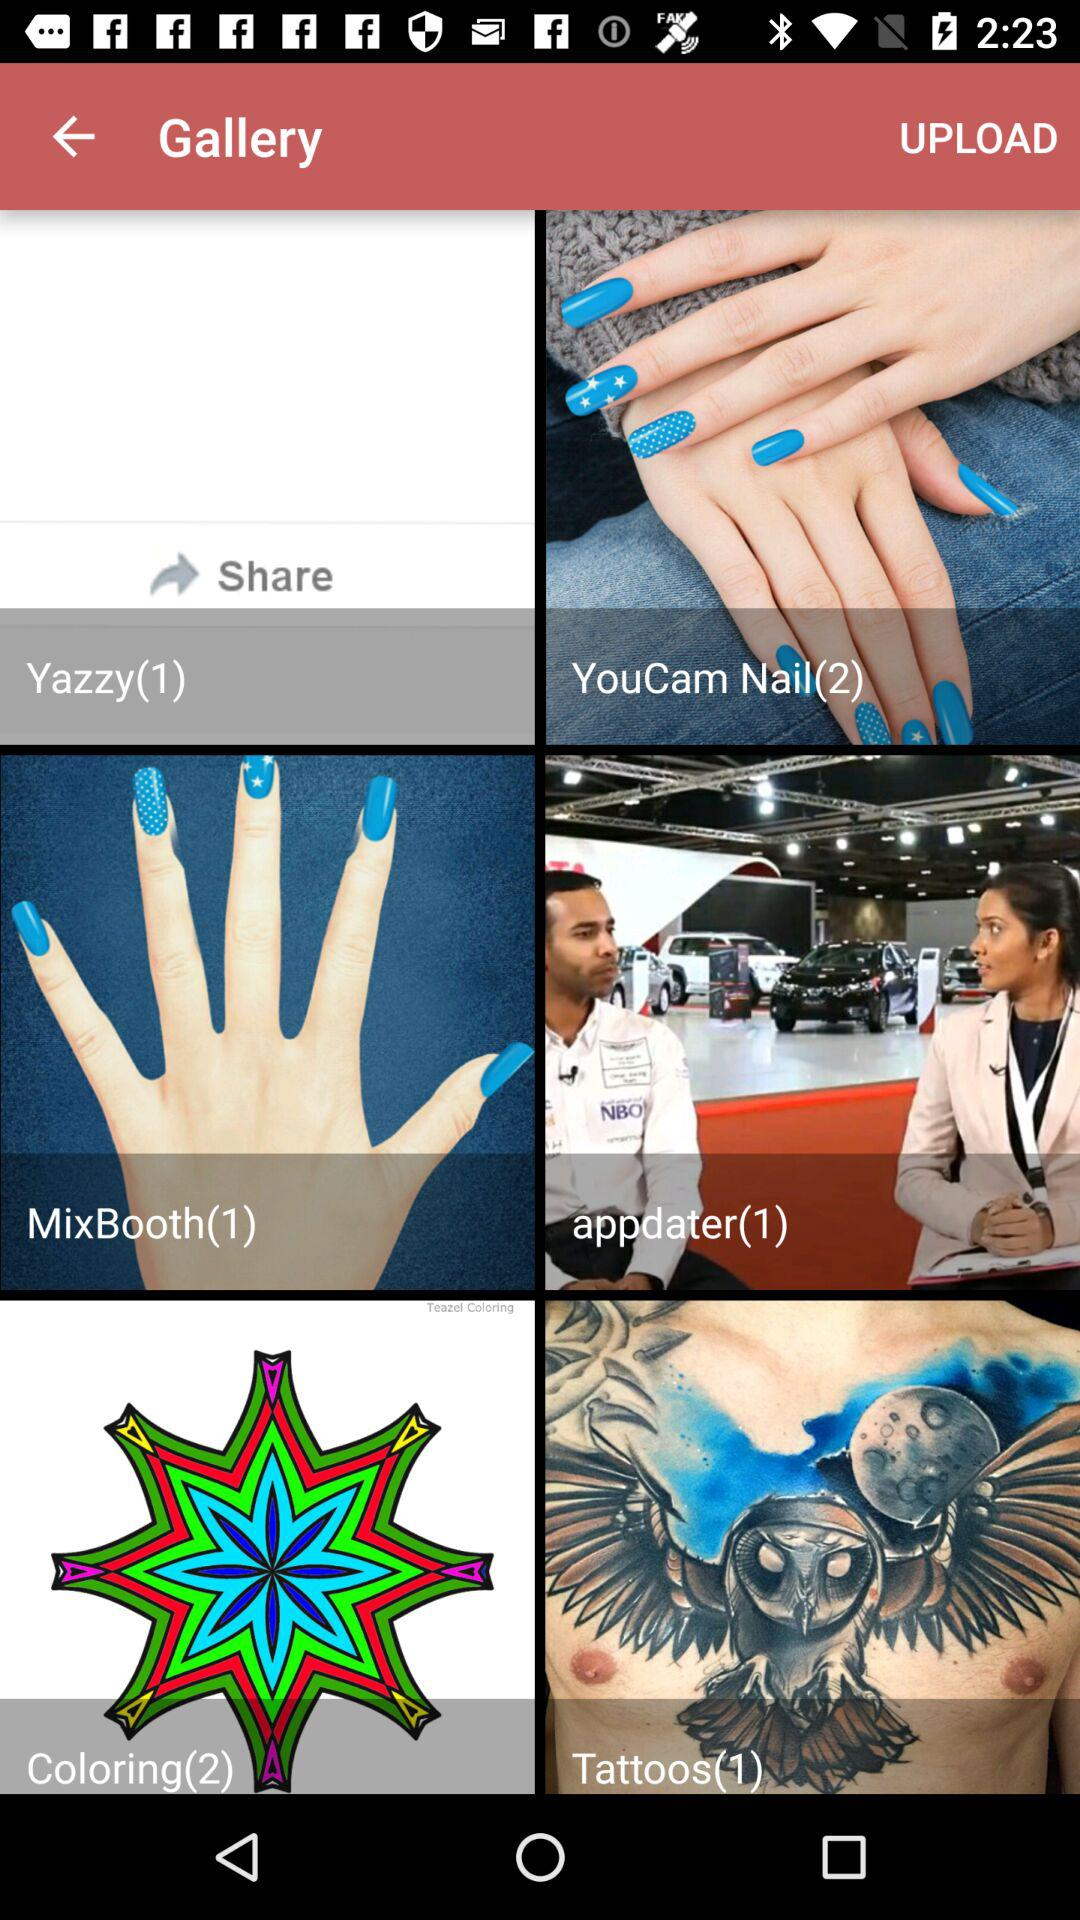How many photos are there in the folder named "Tattoos"? There is 1 photo in the folder named "Tattoos". 